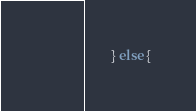<code> <loc_0><loc_0><loc_500><loc_500><_ObjectiveC_>        } else {</code> 